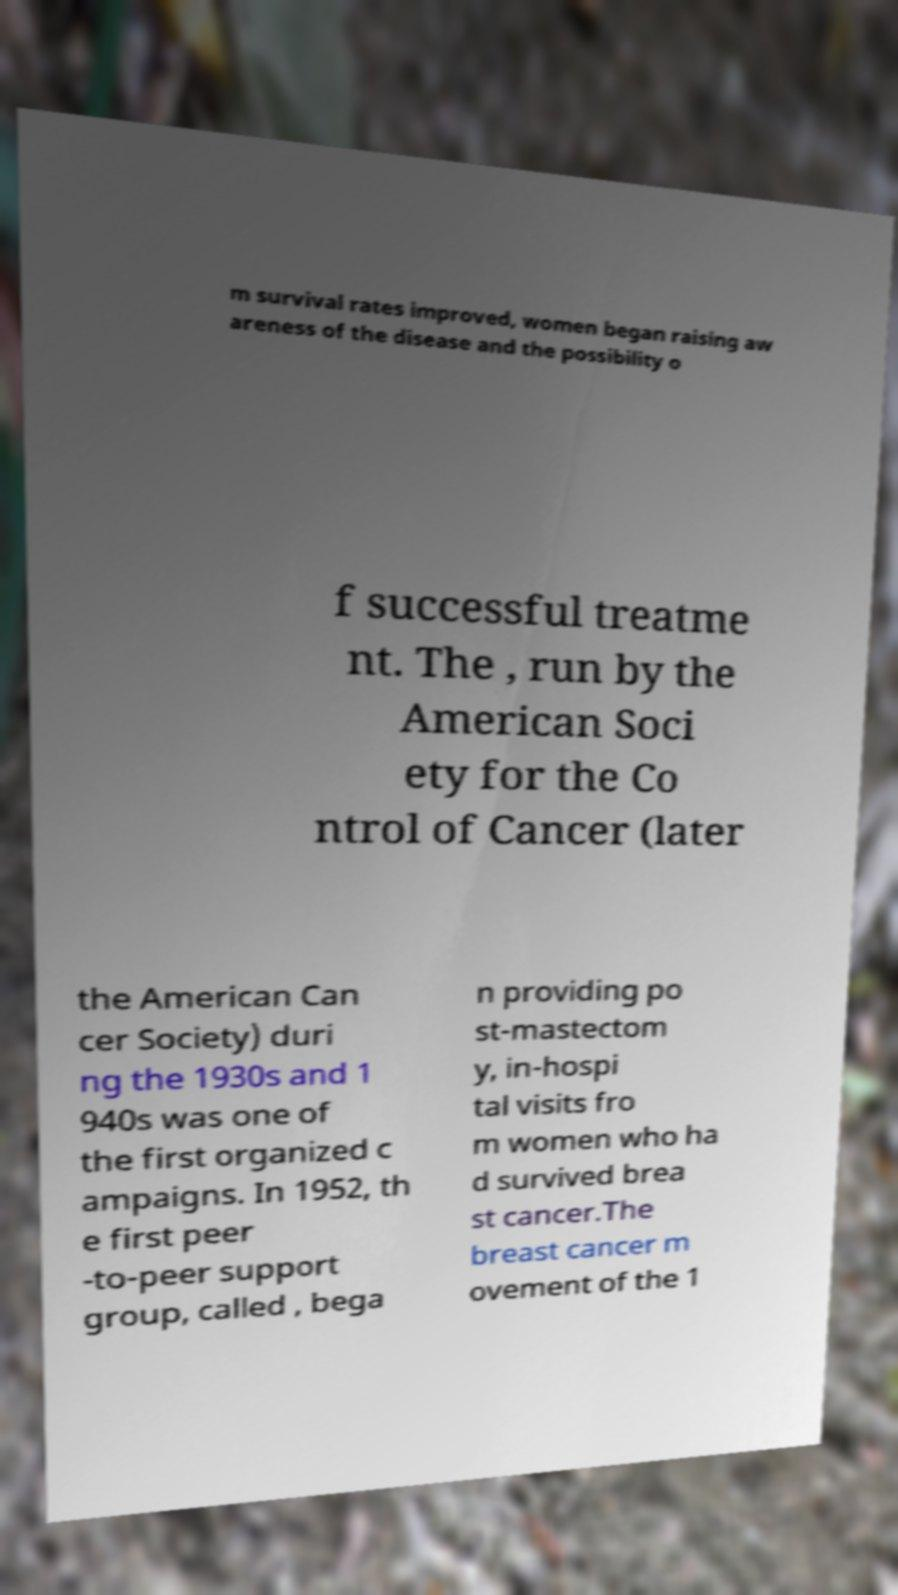For documentation purposes, I need the text within this image transcribed. Could you provide that? m survival rates improved, women began raising aw areness of the disease and the possibility o f successful treatme nt. The , run by the American Soci ety for the Co ntrol of Cancer (later the American Can cer Society) duri ng the 1930s and 1 940s was one of the first organized c ampaigns. In 1952, th e first peer -to-peer support group, called , bega n providing po st-mastectom y, in-hospi tal visits fro m women who ha d survived brea st cancer.The breast cancer m ovement of the 1 